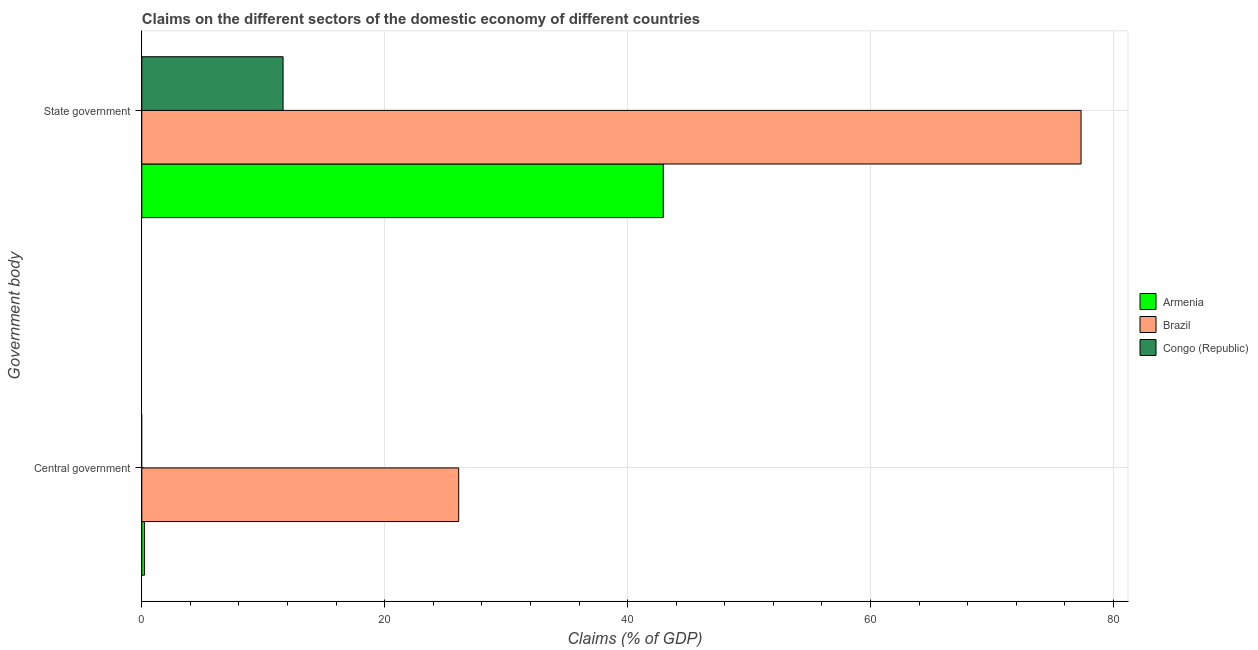How many different coloured bars are there?
Ensure brevity in your answer.  3. How many groups of bars are there?
Your answer should be very brief. 2. Are the number of bars on each tick of the Y-axis equal?
Your answer should be compact. No. How many bars are there on the 1st tick from the top?
Your response must be concise. 3. What is the label of the 2nd group of bars from the top?
Your response must be concise. Central government. Across all countries, what is the maximum claims on central government?
Provide a succinct answer. 26.09. Across all countries, what is the minimum claims on state government?
Ensure brevity in your answer.  11.63. What is the total claims on central government in the graph?
Offer a very short reply. 26.31. What is the difference between the claims on state government in Congo (Republic) and that in Armenia?
Offer a very short reply. -31.3. What is the difference between the claims on central government in Armenia and the claims on state government in Brazil?
Offer a very short reply. -77.12. What is the average claims on state government per country?
Offer a very short reply. 43.97. What is the difference between the claims on central government and claims on state government in Armenia?
Your answer should be compact. -42.72. What is the ratio of the claims on state government in Congo (Republic) to that in Brazil?
Offer a very short reply. 0.15. How many countries are there in the graph?
Offer a very short reply. 3. Are the values on the major ticks of X-axis written in scientific E-notation?
Your answer should be compact. No. Does the graph contain any zero values?
Your answer should be compact. Yes. Where does the legend appear in the graph?
Provide a short and direct response. Center right. How are the legend labels stacked?
Your answer should be very brief. Vertical. What is the title of the graph?
Make the answer very short. Claims on the different sectors of the domestic economy of different countries. What is the label or title of the X-axis?
Provide a short and direct response. Claims (% of GDP). What is the label or title of the Y-axis?
Give a very brief answer. Government body. What is the Claims (% of GDP) of Armenia in Central government?
Provide a short and direct response. 0.22. What is the Claims (% of GDP) in Brazil in Central government?
Give a very brief answer. 26.09. What is the Claims (% of GDP) in Congo (Republic) in Central government?
Offer a terse response. 0. What is the Claims (% of GDP) in Armenia in State government?
Your answer should be very brief. 42.93. What is the Claims (% of GDP) in Brazil in State government?
Offer a terse response. 77.33. What is the Claims (% of GDP) of Congo (Republic) in State government?
Provide a short and direct response. 11.63. Across all Government body, what is the maximum Claims (% of GDP) of Armenia?
Provide a succinct answer. 42.93. Across all Government body, what is the maximum Claims (% of GDP) of Brazil?
Ensure brevity in your answer.  77.33. Across all Government body, what is the maximum Claims (% of GDP) of Congo (Republic)?
Keep it short and to the point. 11.63. Across all Government body, what is the minimum Claims (% of GDP) of Armenia?
Provide a short and direct response. 0.22. Across all Government body, what is the minimum Claims (% of GDP) of Brazil?
Offer a terse response. 26.09. Across all Government body, what is the minimum Claims (% of GDP) in Congo (Republic)?
Provide a short and direct response. 0. What is the total Claims (% of GDP) in Armenia in the graph?
Offer a terse response. 43.15. What is the total Claims (% of GDP) of Brazil in the graph?
Provide a short and direct response. 103.42. What is the total Claims (% of GDP) in Congo (Republic) in the graph?
Provide a short and direct response. 11.63. What is the difference between the Claims (% of GDP) in Armenia in Central government and that in State government?
Offer a terse response. -42.72. What is the difference between the Claims (% of GDP) in Brazil in Central government and that in State government?
Provide a short and direct response. -51.24. What is the difference between the Claims (% of GDP) in Armenia in Central government and the Claims (% of GDP) in Brazil in State government?
Offer a terse response. -77.12. What is the difference between the Claims (% of GDP) of Armenia in Central government and the Claims (% of GDP) of Congo (Republic) in State government?
Give a very brief answer. -11.42. What is the difference between the Claims (% of GDP) in Brazil in Central government and the Claims (% of GDP) in Congo (Republic) in State government?
Offer a very short reply. 14.46. What is the average Claims (% of GDP) of Armenia per Government body?
Your answer should be compact. 21.57. What is the average Claims (% of GDP) in Brazil per Government body?
Provide a succinct answer. 51.71. What is the average Claims (% of GDP) of Congo (Republic) per Government body?
Provide a short and direct response. 5.82. What is the difference between the Claims (% of GDP) of Armenia and Claims (% of GDP) of Brazil in Central government?
Give a very brief answer. -25.87. What is the difference between the Claims (% of GDP) of Armenia and Claims (% of GDP) of Brazil in State government?
Offer a terse response. -34.4. What is the difference between the Claims (% of GDP) in Armenia and Claims (% of GDP) in Congo (Republic) in State government?
Give a very brief answer. 31.3. What is the difference between the Claims (% of GDP) of Brazil and Claims (% of GDP) of Congo (Republic) in State government?
Make the answer very short. 65.7. What is the ratio of the Claims (% of GDP) in Armenia in Central government to that in State government?
Offer a terse response. 0.01. What is the ratio of the Claims (% of GDP) in Brazil in Central government to that in State government?
Your answer should be very brief. 0.34. What is the difference between the highest and the second highest Claims (% of GDP) in Armenia?
Ensure brevity in your answer.  42.72. What is the difference between the highest and the second highest Claims (% of GDP) of Brazil?
Provide a short and direct response. 51.24. What is the difference between the highest and the lowest Claims (% of GDP) of Armenia?
Provide a short and direct response. 42.72. What is the difference between the highest and the lowest Claims (% of GDP) of Brazil?
Ensure brevity in your answer.  51.24. What is the difference between the highest and the lowest Claims (% of GDP) of Congo (Republic)?
Ensure brevity in your answer.  11.63. 